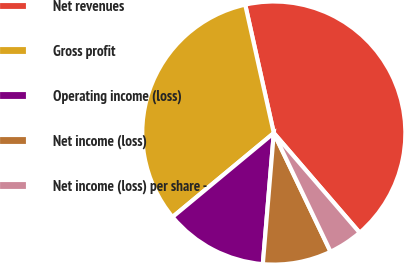<chart> <loc_0><loc_0><loc_500><loc_500><pie_chart><fcel>Net revenues<fcel>Gross profit<fcel>Operating income (loss)<fcel>Net income (loss)<fcel>Net income (loss) per share -<nl><fcel>42.17%<fcel>32.53%<fcel>12.65%<fcel>8.43%<fcel>4.22%<nl></chart> 